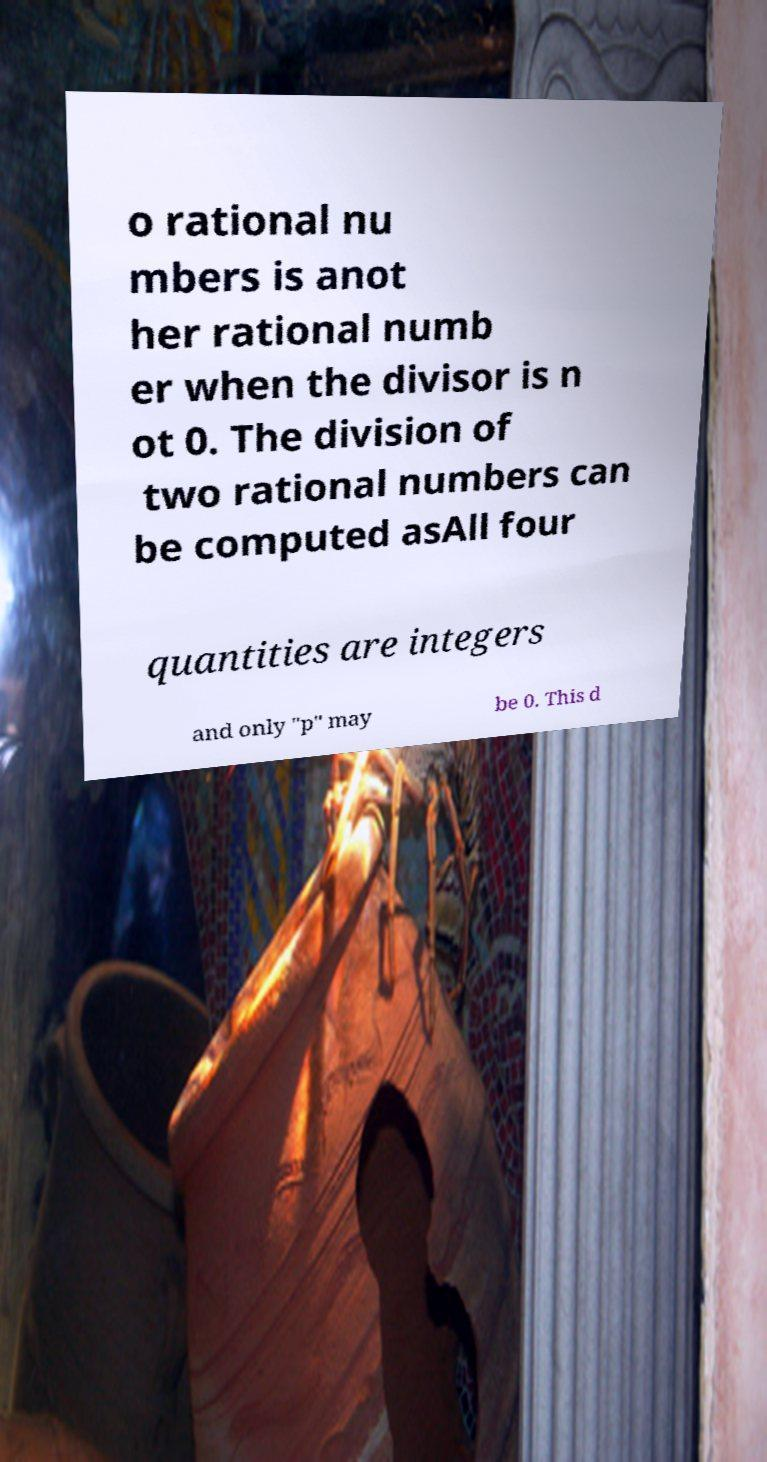Please identify and transcribe the text found in this image. o rational nu mbers is anot her rational numb er when the divisor is n ot 0. The division of two rational numbers can be computed asAll four quantities are integers and only "p" may be 0. This d 